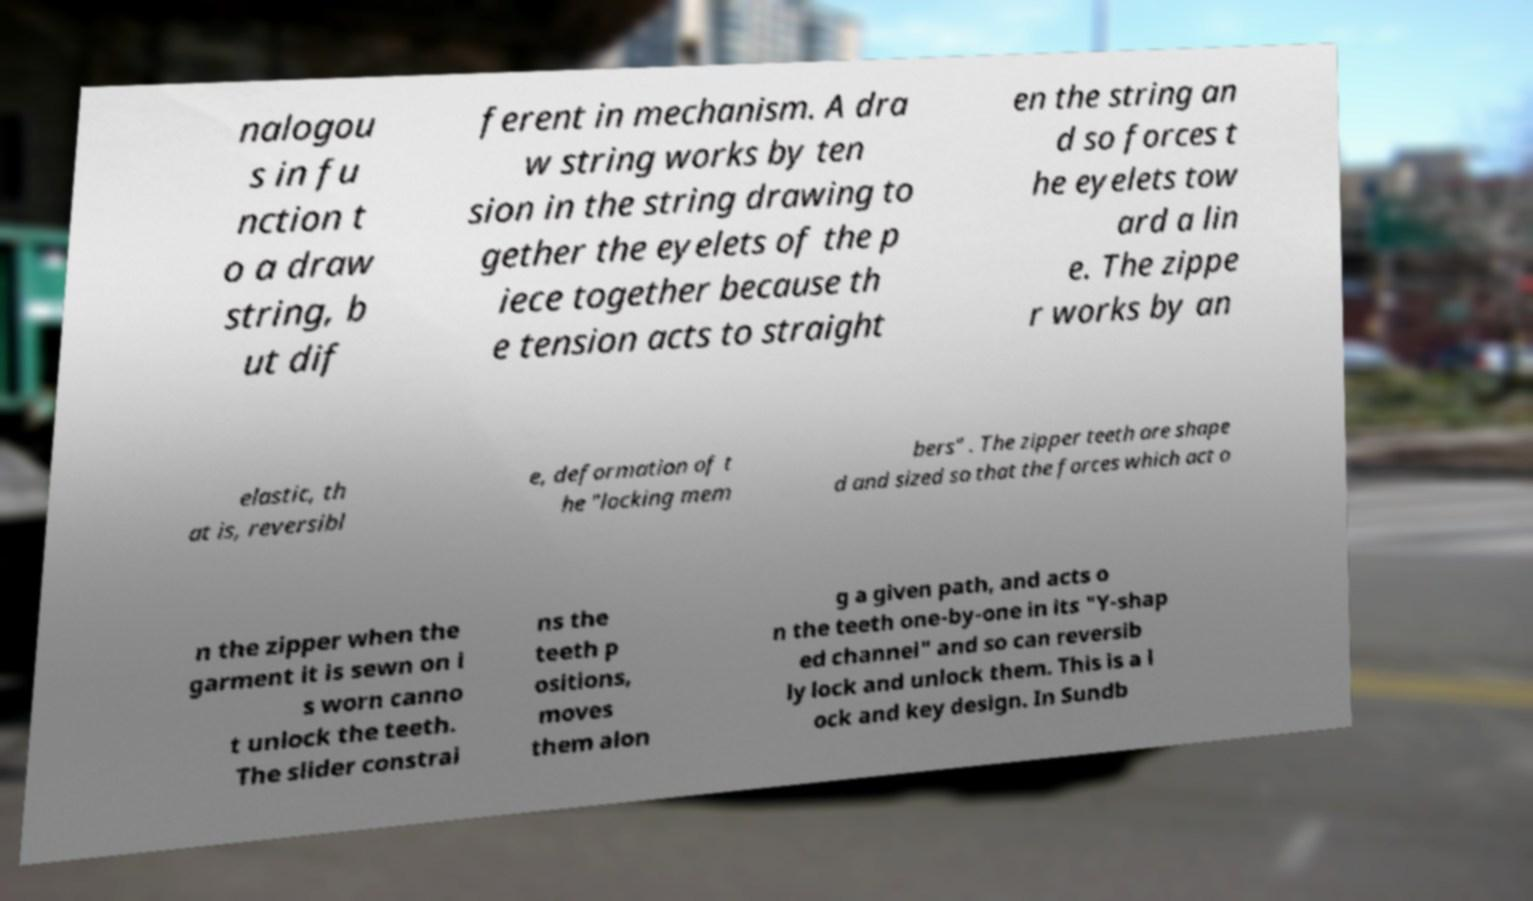Can you read and provide the text displayed in the image?This photo seems to have some interesting text. Can you extract and type it out for me? nalogou s in fu nction t o a draw string, b ut dif ferent in mechanism. A dra w string works by ten sion in the string drawing to gether the eyelets of the p iece together because th e tension acts to straight en the string an d so forces t he eyelets tow ard a lin e. The zippe r works by an elastic, th at is, reversibl e, deformation of t he "locking mem bers" . The zipper teeth are shape d and sized so that the forces which act o n the zipper when the garment it is sewn on i s worn canno t unlock the teeth. The slider constrai ns the teeth p ositions, moves them alon g a given path, and acts o n the teeth one-by-one in its "Y-shap ed channel" and so can reversib ly lock and unlock them. This is a l ock and key design. In Sundb 